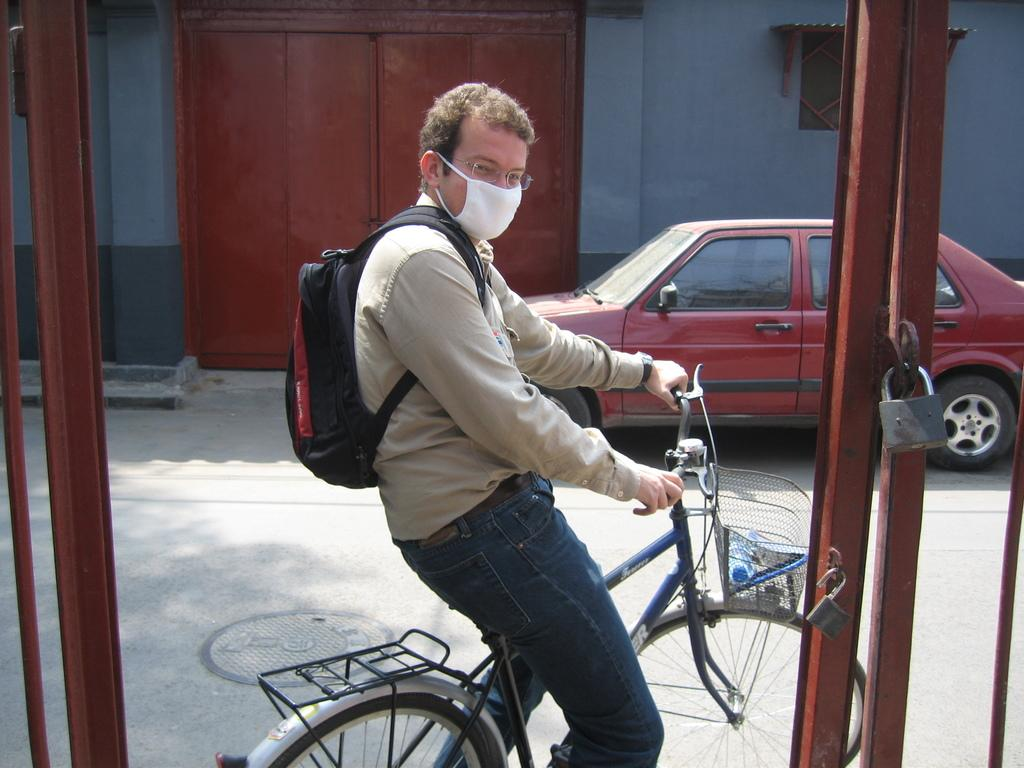What is the man doing in the image? The man is standing on a bicycle. What else can be seen on the right side of the image? There is a car on the right side of the image. What is the background of the image? There is a wall in the image. How many grapes are on the man's head in the image? There are no grapes present on the man's head in the image. 